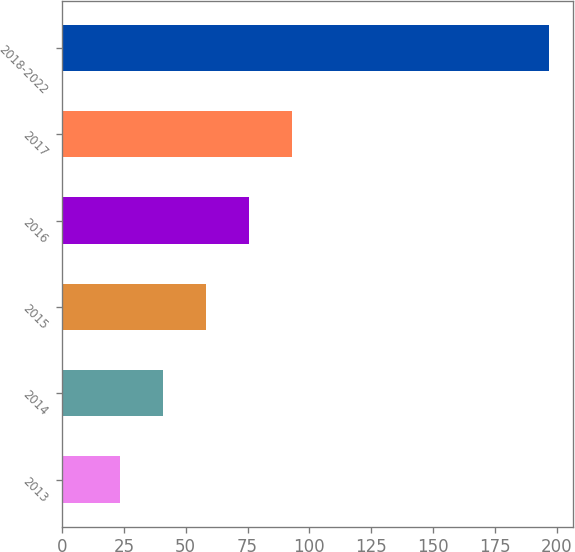<chart> <loc_0><loc_0><loc_500><loc_500><bar_chart><fcel>2013<fcel>2014<fcel>2015<fcel>2016<fcel>2017<fcel>2018-2022<nl><fcel>23.4<fcel>40.75<fcel>58.1<fcel>75.45<fcel>92.8<fcel>196.9<nl></chart> 